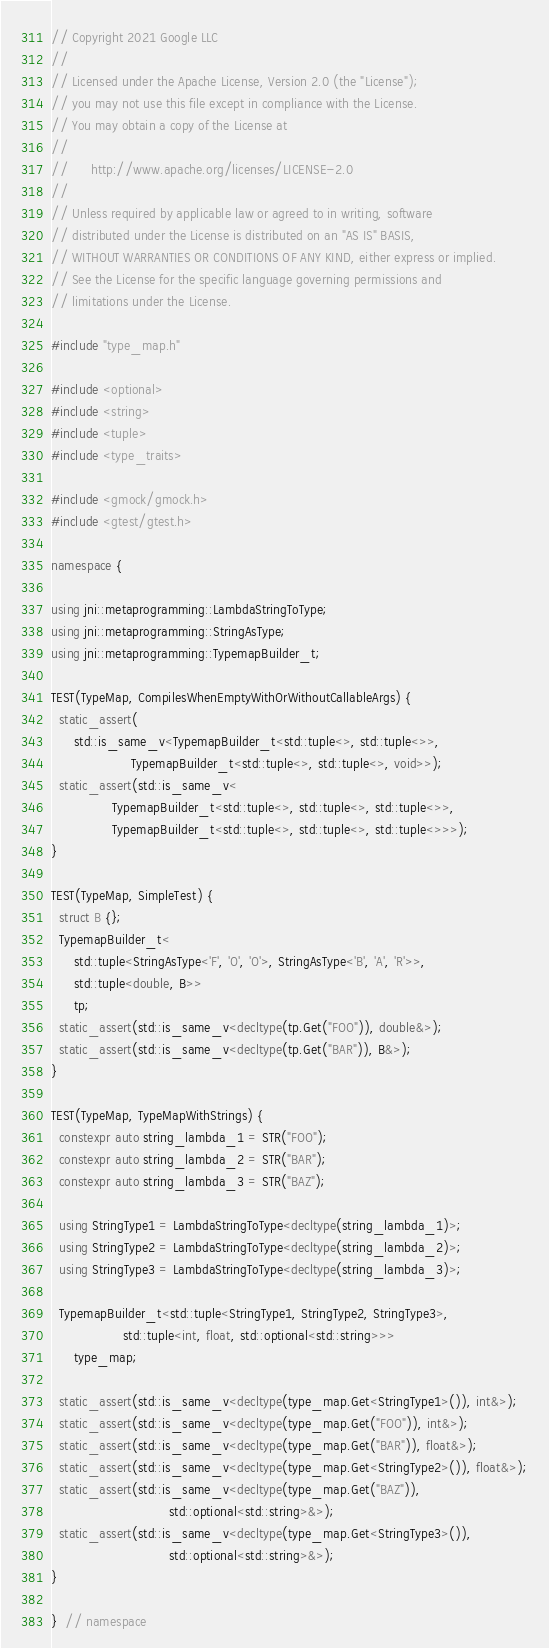Convert code to text. <code><loc_0><loc_0><loc_500><loc_500><_C++_>// Copyright 2021 Google LLC
//
// Licensed under the Apache License, Version 2.0 (the "License");
// you may not use this file except in compliance with the License.
// You may obtain a copy of the License at
//
//      http://www.apache.org/licenses/LICENSE-2.0
//
// Unless required by applicable law or agreed to in writing, software
// distributed under the License is distributed on an "AS IS" BASIS,
// WITHOUT WARRANTIES OR CONDITIONS OF ANY KIND, either express or implied.
// See the License for the specific language governing permissions and
// limitations under the License.

#include "type_map.h"

#include <optional>
#include <string>
#include <tuple>
#include <type_traits>

#include <gmock/gmock.h>
#include <gtest/gtest.h>

namespace {

using jni::metaprogramming::LambdaStringToType;
using jni::metaprogramming::StringAsType;
using jni::metaprogramming::TypemapBuilder_t;

TEST(TypeMap, CompilesWhenEmptyWithOrWithoutCallableArgs) {
  static_assert(
      std::is_same_v<TypemapBuilder_t<std::tuple<>, std::tuple<>>,
                     TypemapBuilder_t<std::tuple<>, std::tuple<>, void>>);
  static_assert(std::is_same_v<
                TypemapBuilder_t<std::tuple<>, std::tuple<>, std::tuple<>>,
                TypemapBuilder_t<std::tuple<>, std::tuple<>, std::tuple<>>>);
}

TEST(TypeMap, SimpleTest) {
  struct B {};
  TypemapBuilder_t<
      std::tuple<StringAsType<'F', 'O', 'O'>, StringAsType<'B', 'A', 'R'>>,
      std::tuple<double, B>>
      tp;
  static_assert(std::is_same_v<decltype(tp.Get("FOO")), double&>);
  static_assert(std::is_same_v<decltype(tp.Get("BAR")), B&>);
}

TEST(TypeMap, TypeMapWithStrings) {
  constexpr auto string_lambda_1 = STR("FOO");
  constexpr auto string_lambda_2 = STR("BAR");
  constexpr auto string_lambda_3 = STR("BAZ");

  using StringType1 = LambdaStringToType<decltype(string_lambda_1)>;
  using StringType2 = LambdaStringToType<decltype(string_lambda_2)>;
  using StringType3 = LambdaStringToType<decltype(string_lambda_3)>;

  TypemapBuilder_t<std::tuple<StringType1, StringType2, StringType3>,
                   std::tuple<int, float, std::optional<std::string>>>
      type_map;

  static_assert(std::is_same_v<decltype(type_map.Get<StringType1>()), int&>);
  static_assert(std::is_same_v<decltype(type_map.Get("FOO")), int&>);
  static_assert(std::is_same_v<decltype(type_map.Get("BAR")), float&>);
  static_assert(std::is_same_v<decltype(type_map.Get<StringType2>()), float&>);
  static_assert(std::is_same_v<decltype(type_map.Get("BAZ")),
                               std::optional<std::string>&>);
  static_assert(std::is_same_v<decltype(type_map.Get<StringType3>()),
                               std::optional<std::string>&>);
}

}  // namespace
</code> 